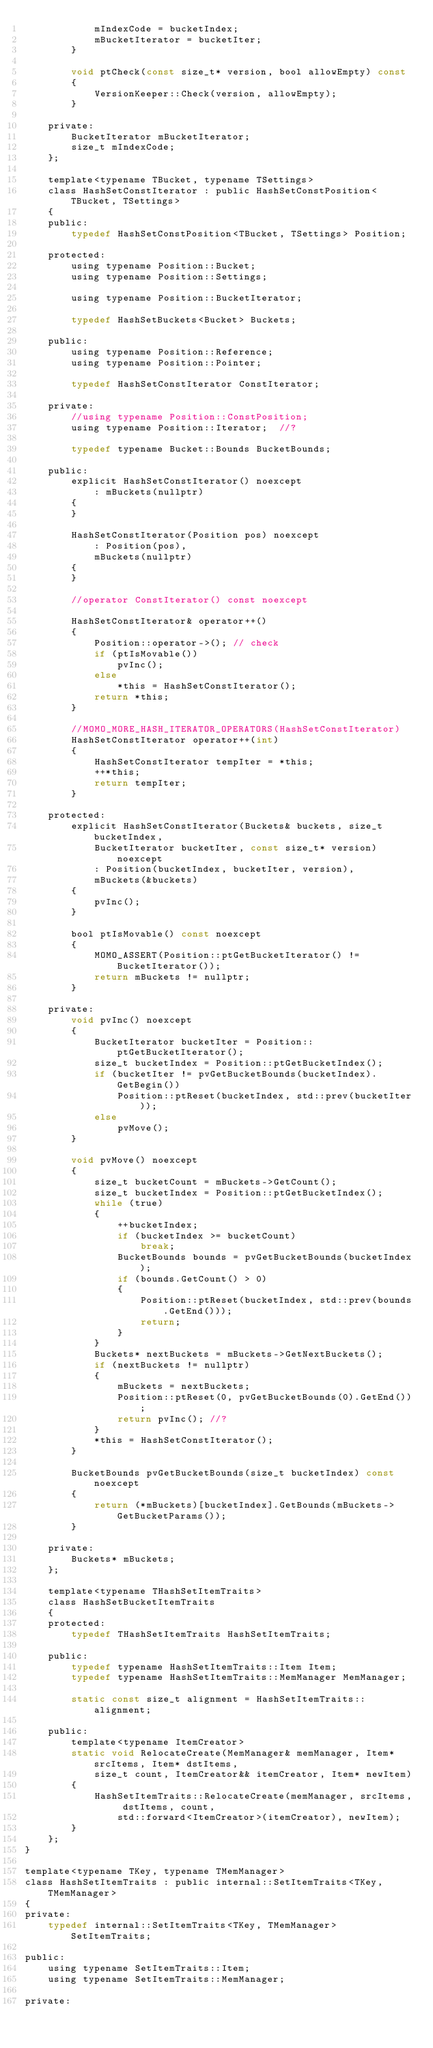<code> <loc_0><loc_0><loc_500><loc_500><_C_>			mIndexCode = bucketIndex;
			mBucketIterator = bucketIter;
		}

		void ptCheck(const size_t* version, bool allowEmpty) const
		{
			VersionKeeper::Check(version, allowEmpty);
		}

	private:
		BucketIterator mBucketIterator;
		size_t mIndexCode;
	};

	template<typename TBucket, typename TSettings>
	class HashSetConstIterator : public HashSetConstPosition<TBucket, TSettings>
	{
	public:
		typedef HashSetConstPosition<TBucket, TSettings> Position;

	protected:
		using typename Position::Bucket;
		using typename Position::Settings;

		using typename Position::BucketIterator;

		typedef HashSetBuckets<Bucket> Buckets;

	public:
		using typename Position::Reference;
		using typename Position::Pointer;

		typedef HashSetConstIterator ConstIterator;

	private:
		//using typename Position::ConstPosition;
		using typename Position::Iterator;	//?

		typedef typename Bucket::Bounds BucketBounds;

	public:
		explicit HashSetConstIterator() noexcept
			: mBuckets(nullptr)
		{
		}

		HashSetConstIterator(Position pos) noexcept
			: Position(pos),
			mBuckets(nullptr)
		{
		}

		//operator ConstIterator() const noexcept

		HashSetConstIterator& operator++()
		{
			Position::operator->();	// check
			if (ptIsMovable())
				pvInc();
			else
				*this = HashSetConstIterator();
			return *this;
		}

		//MOMO_MORE_HASH_ITERATOR_OPERATORS(HashSetConstIterator)
		HashSetConstIterator operator++(int)
		{
			HashSetConstIterator tempIter = *this;
			++*this;
			return tempIter;
		}

	protected:
		explicit HashSetConstIterator(Buckets& buckets, size_t bucketIndex,
			BucketIterator bucketIter, const size_t* version) noexcept
			: Position(bucketIndex, bucketIter, version),
			mBuckets(&buckets)
		{
			pvInc();
		}

		bool ptIsMovable() const noexcept
		{
			MOMO_ASSERT(Position::ptGetBucketIterator() != BucketIterator());
			return mBuckets != nullptr;
		}

	private:
		void pvInc() noexcept
		{
			BucketIterator bucketIter = Position::ptGetBucketIterator();
			size_t bucketIndex = Position::ptGetBucketIndex();
			if (bucketIter != pvGetBucketBounds(bucketIndex).GetBegin())
				Position::ptReset(bucketIndex, std::prev(bucketIter));
			else
				pvMove();
		}

		void pvMove() noexcept
		{
			size_t bucketCount = mBuckets->GetCount();
			size_t bucketIndex = Position::ptGetBucketIndex();
			while (true)
			{
				++bucketIndex;
				if (bucketIndex >= bucketCount)
					break;
				BucketBounds bounds = pvGetBucketBounds(bucketIndex);
				if (bounds.GetCount() > 0)
				{
					Position::ptReset(bucketIndex, std::prev(bounds.GetEnd()));
					return;
				}
			}
			Buckets* nextBuckets = mBuckets->GetNextBuckets();
			if (nextBuckets != nullptr)
			{
				mBuckets = nextBuckets;
				Position::ptReset(0, pvGetBucketBounds(0).GetEnd());
				return pvInc();	//?
			}
			*this = HashSetConstIterator();
		}

		BucketBounds pvGetBucketBounds(size_t bucketIndex) const noexcept
		{
			return (*mBuckets)[bucketIndex].GetBounds(mBuckets->GetBucketParams());
		}

	private:
		Buckets* mBuckets;
	};

	template<typename THashSetItemTraits>
	class HashSetBucketItemTraits
	{
	protected:
		typedef THashSetItemTraits HashSetItemTraits;

	public:
		typedef typename HashSetItemTraits::Item Item;
		typedef typename HashSetItemTraits::MemManager MemManager;

		static const size_t alignment = HashSetItemTraits::alignment;

	public:
		template<typename ItemCreator>
		static void RelocateCreate(MemManager& memManager, Item* srcItems, Item* dstItems,
			size_t count, ItemCreator&& itemCreator, Item* newItem)
		{
			HashSetItemTraits::RelocateCreate(memManager, srcItems, dstItems, count,
				std::forward<ItemCreator>(itemCreator), newItem);
		}
	};
}

template<typename TKey, typename TMemManager>
class HashSetItemTraits : public internal::SetItemTraits<TKey, TMemManager>
{
private:
	typedef internal::SetItemTraits<TKey, TMemManager> SetItemTraits;

public:
	using typename SetItemTraits::Item;
	using typename SetItemTraits::MemManager;

private:</code> 